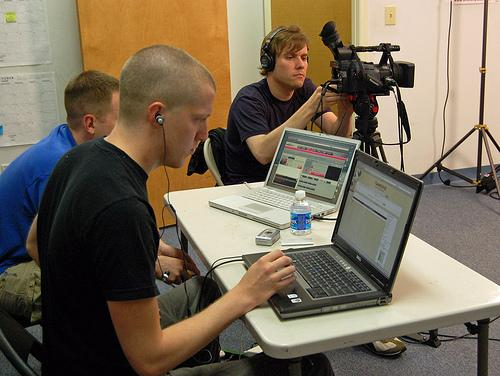Which one is doing silent work?

Choices:
A) none
B) middle
C) right
D) left middle 